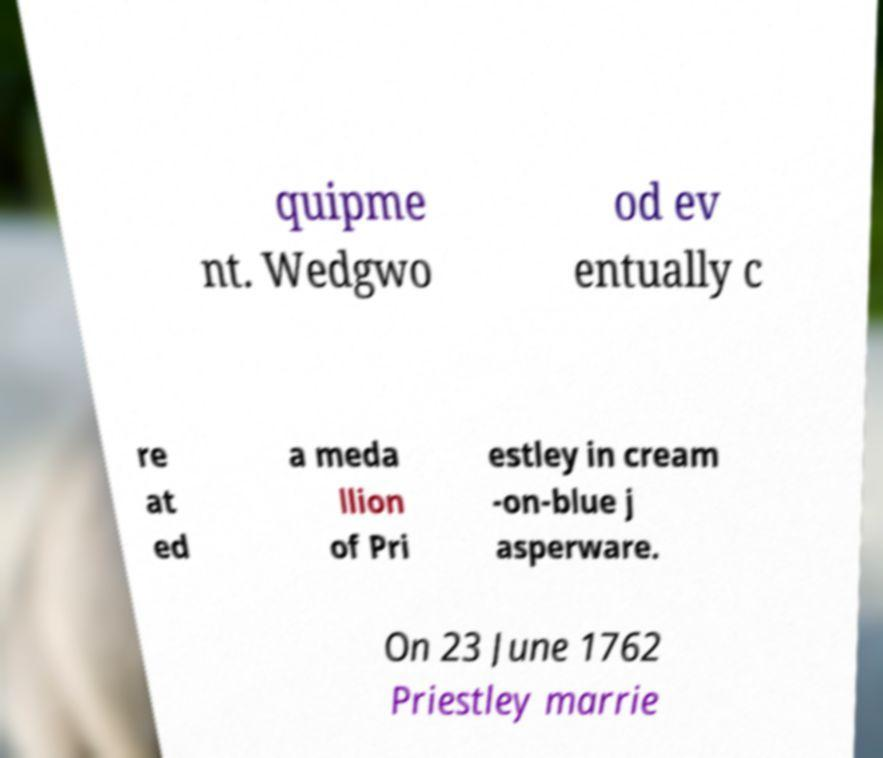There's text embedded in this image that I need extracted. Can you transcribe it verbatim? quipme nt. Wedgwo od ev entually c re at ed a meda llion of Pri estley in cream -on-blue j asperware. On 23 June 1762 Priestley marrie 